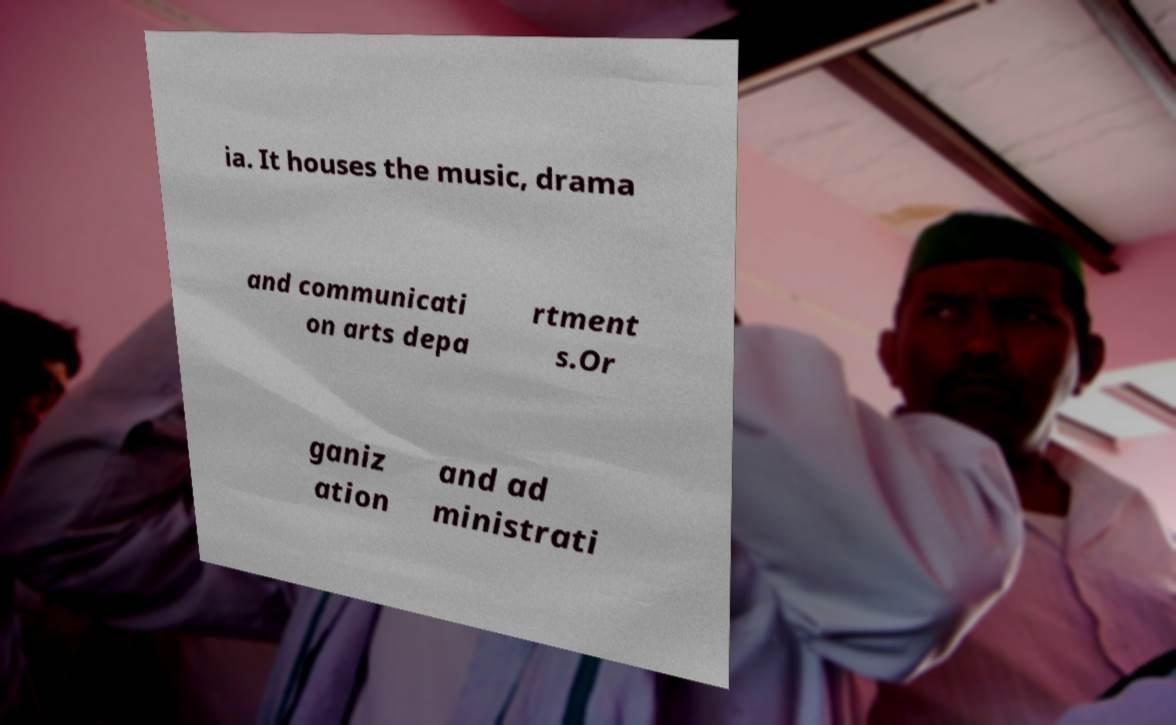Can you accurately transcribe the text from the provided image for me? ia. It houses the music, drama and communicati on arts depa rtment s.Or ganiz ation and ad ministrati 